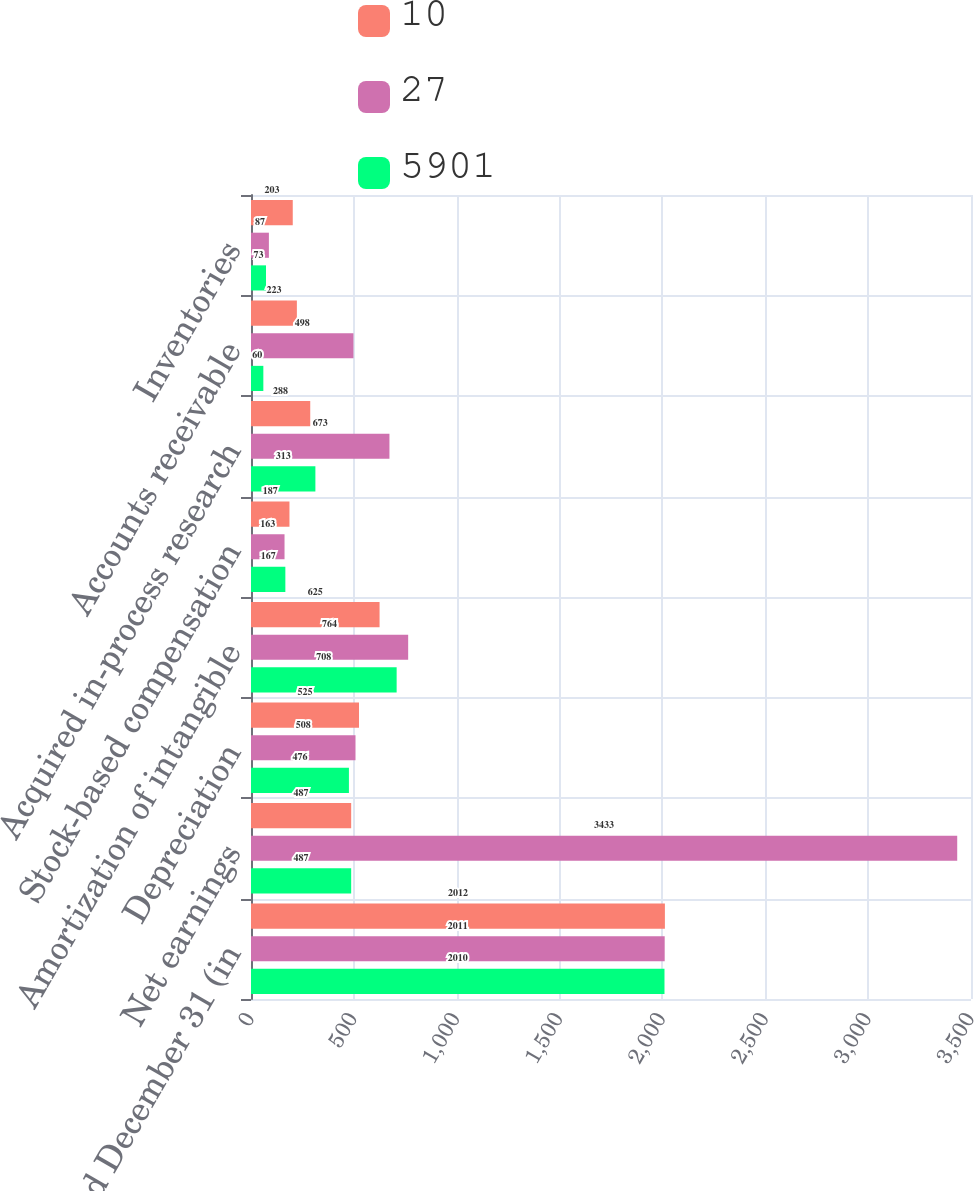Convert chart to OTSL. <chart><loc_0><loc_0><loc_500><loc_500><stacked_bar_chart><ecel><fcel>years ended December 31 (in<fcel>Net earnings<fcel>Depreciation<fcel>Amortization of intangible<fcel>Stock-based compensation<fcel>Acquired in-process research<fcel>Accounts receivable<fcel>Inventories<nl><fcel>10<fcel>2012<fcel>487<fcel>525<fcel>625<fcel>187<fcel>288<fcel>223<fcel>203<nl><fcel>27<fcel>2011<fcel>3433<fcel>508<fcel>764<fcel>163<fcel>673<fcel>498<fcel>87<nl><fcel>5901<fcel>2010<fcel>487<fcel>476<fcel>708<fcel>167<fcel>313<fcel>60<fcel>73<nl></chart> 